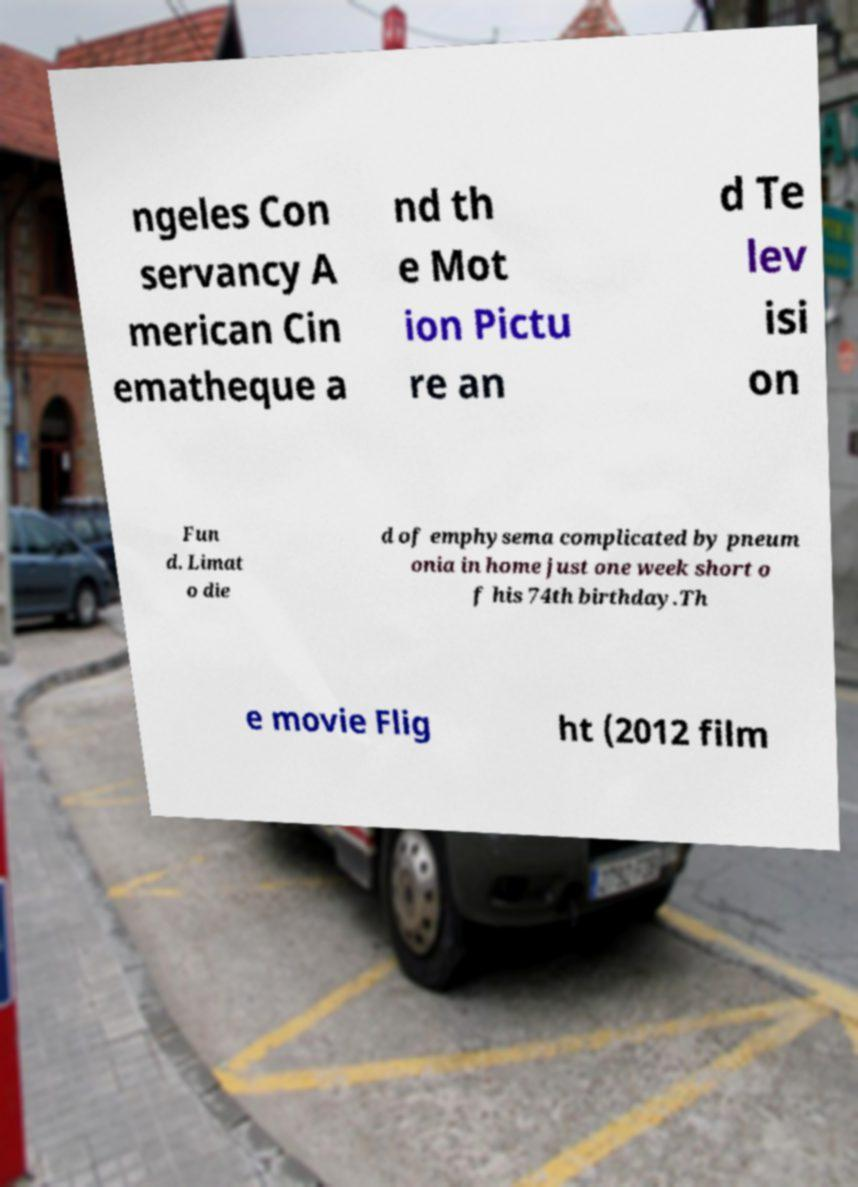There's text embedded in this image that I need extracted. Can you transcribe it verbatim? ngeles Con servancy A merican Cin ematheque a nd th e Mot ion Pictu re an d Te lev isi on Fun d. Limat o die d of emphysema complicated by pneum onia in home just one week short o f his 74th birthday.Th e movie Flig ht (2012 film 